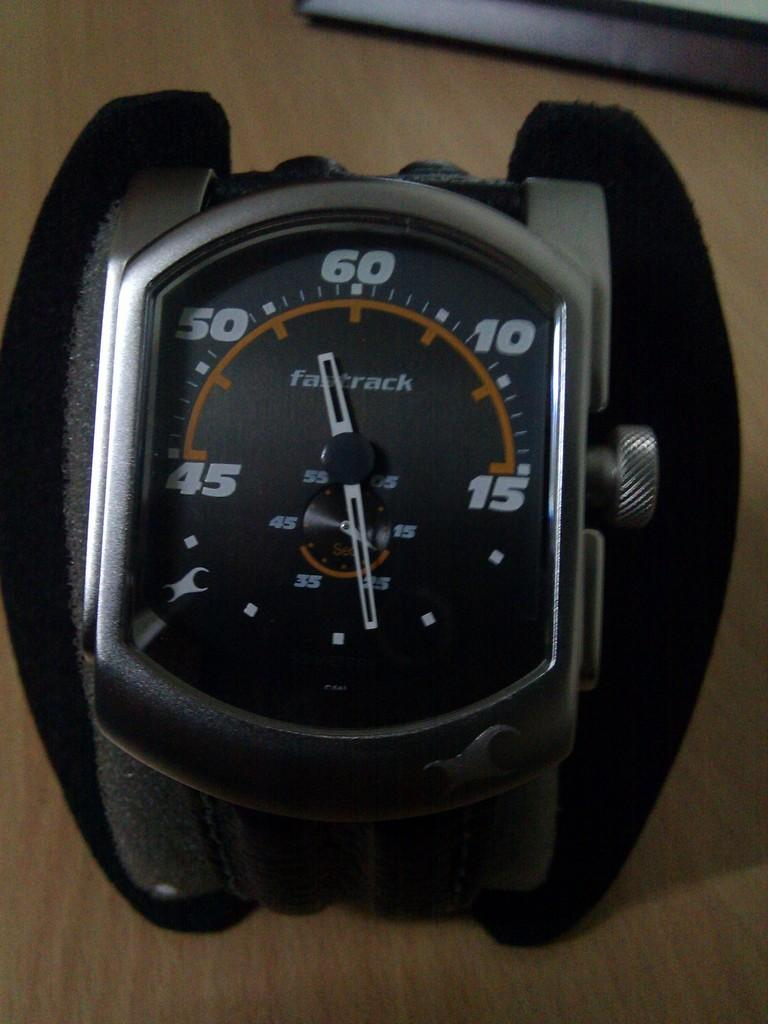<image>
Relay a brief, clear account of the picture shown. A black watch is sitting on a desk and has the number 60 on it. 